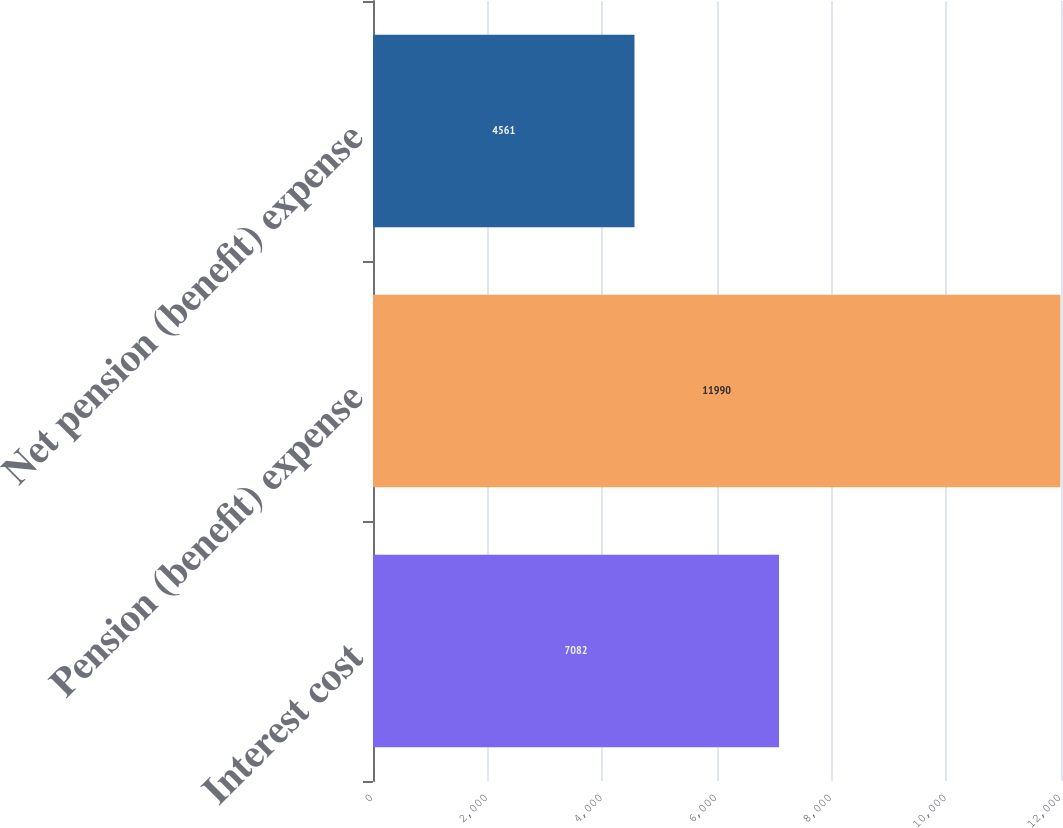Convert chart. <chart><loc_0><loc_0><loc_500><loc_500><bar_chart><fcel>Interest cost<fcel>Pension (benefit) expense<fcel>Net pension (benefit) expense<nl><fcel>7082<fcel>11990<fcel>4561<nl></chart> 